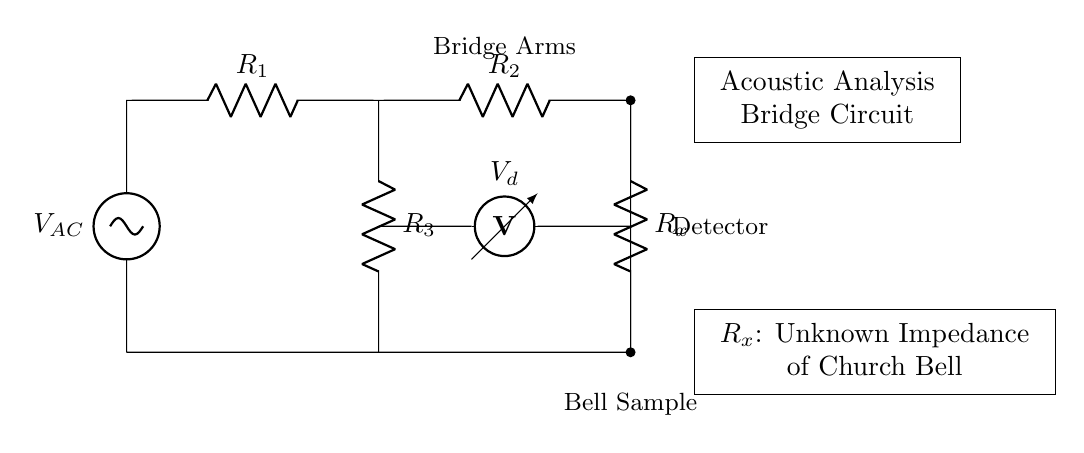What type of voltage source is used in the circuit? The circuit uses an alternating current voltage source, as indicated by the symbol 'vsourcesin'.
Answer: Alternating current What are the values indicated for resistors R1 and R2? The values for R1 and R2 are not specified in the circuit diagram, as they're only labeled without numerical values, which is common for illustrative purposes.
Answer: Undefined How many resistors are there in the circuit? The circuit contains four resistors, R1, R2, R3, and Rx, which are all integral to the bridge configuration.
Answer: Four What does the voltmeter measure in this circuit? The voltmeter in this circuit measures the voltage difference across R3 and Rx, helpful for analyzing the balance of the bridge.
Answer: Voltage difference What is the role of the unknown impedance Rx in the circuit? The unknown impedance Rx represents the acoustic properties of the church bell being analyzed, essential for determining the characteristics of the bell.
Answer: Church bell properties What can be inferred about the bridge's balance condition? The bridge's balance condition occurs when the voltage measured by the voltmeter is zero, indicating equal impedance in both paths of the bridge.
Answer: Zero voltage What is the function of the detector in this circuit? The detector's function is to sense the voltage readings from the voltmeter, which aids in determining the bridge's balance and the impedance of the bell.
Answer: Voltage sensing 